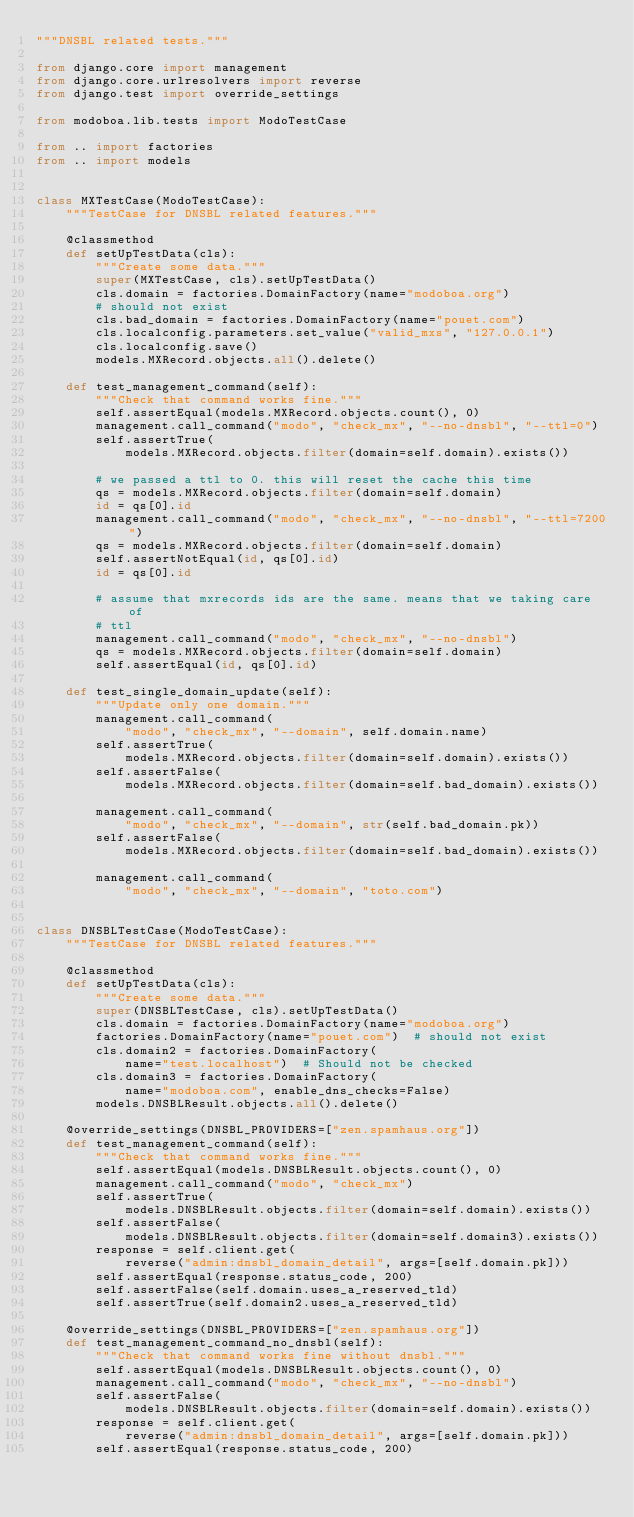Convert code to text. <code><loc_0><loc_0><loc_500><loc_500><_Python_>"""DNSBL related tests."""

from django.core import management
from django.core.urlresolvers import reverse
from django.test import override_settings

from modoboa.lib.tests import ModoTestCase

from .. import factories
from .. import models


class MXTestCase(ModoTestCase):
    """TestCase for DNSBL related features."""

    @classmethod
    def setUpTestData(cls):
        """Create some data."""
        super(MXTestCase, cls).setUpTestData()
        cls.domain = factories.DomainFactory(name="modoboa.org")
        # should not exist
        cls.bad_domain = factories.DomainFactory(name="pouet.com")
        cls.localconfig.parameters.set_value("valid_mxs", "127.0.0.1")
        cls.localconfig.save()
        models.MXRecord.objects.all().delete()

    def test_management_command(self):
        """Check that command works fine."""
        self.assertEqual(models.MXRecord.objects.count(), 0)
        management.call_command("modo", "check_mx", "--no-dnsbl", "--ttl=0")
        self.assertTrue(
            models.MXRecord.objects.filter(domain=self.domain).exists())

        # we passed a ttl to 0. this will reset the cache this time
        qs = models.MXRecord.objects.filter(domain=self.domain)
        id = qs[0].id
        management.call_command("modo", "check_mx", "--no-dnsbl", "--ttl=7200")
        qs = models.MXRecord.objects.filter(domain=self.domain)
        self.assertNotEqual(id, qs[0].id)
        id = qs[0].id

        # assume that mxrecords ids are the same. means that we taking care of
        # ttl
        management.call_command("modo", "check_mx", "--no-dnsbl")
        qs = models.MXRecord.objects.filter(domain=self.domain)
        self.assertEqual(id, qs[0].id)

    def test_single_domain_update(self):
        """Update only one domain."""
        management.call_command(
            "modo", "check_mx", "--domain", self.domain.name)
        self.assertTrue(
            models.MXRecord.objects.filter(domain=self.domain).exists())
        self.assertFalse(
            models.MXRecord.objects.filter(domain=self.bad_domain).exists())

        management.call_command(
            "modo", "check_mx", "--domain", str(self.bad_domain.pk))
        self.assertFalse(
            models.MXRecord.objects.filter(domain=self.bad_domain).exists())

        management.call_command(
            "modo", "check_mx", "--domain", "toto.com")


class DNSBLTestCase(ModoTestCase):
    """TestCase for DNSBL related features."""

    @classmethod
    def setUpTestData(cls):
        """Create some data."""
        super(DNSBLTestCase, cls).setUpTestData()
        cls.domain = factories.DomainFactory(name="modoboa.org")
        factories.DomainFactory(name="pouet.com")  # should not exist
        cls.domain2 = factories.DomainFactory(
            name="test.localhost")  # Should not be checked
        cls.domain3 = factories.DomainFactory(
            name="modoboa.com", enable_dns_checks=False)
        models.DNSBLResult.objects.all().delete()

    @override_settings(DNSBL_PROVIDERS=["zen.spamhaus.org"])
    def test_management_command(self):
        """Check that command works fine."""
        self.assertEqual(models.DNSBLResult.objects.count(), 0)
        management.call_command("modo", "check_mx")
        self.assertTrue(
            models.DNSBLResult.objects.filter(domain=self.domain).exists())
        self.assertFalse(
            models.DNSBLResult.objects.filter(domain=self.domain3).exists())
        response = self.client.get(
            reverse("admin:dnsbl_domain_detail", args=[self.domain.pk]))
        self.assertEqual(response.status_code, 200)
        self.assertFalse(self.domain.uses_a_reserved_tld)
        self.assertTrue(self.domain2.uses_a_reserved_tld)

    @override_settings(DNSBL_PROVIDERS=["zen.spamhaus.org"])
    def test_management_command_no_dnsbl(self):
        """Check that command works fine without dnsbl."""
        self.assertEqual(models.DNSBLResult.objects.count(), 0)
        management.call_command("modo", "check_mx", "--no-dnsbl")
        self.assertFalse(
            models.DNSBLResult.objects.filter(domain=self.domain).exists())
        response = self.client.get(
            reverse("admin:dnsbl_domain_detail", args=[self.domain.pk]))
        self.assertEqual(response.status_code, 200)
</code> 